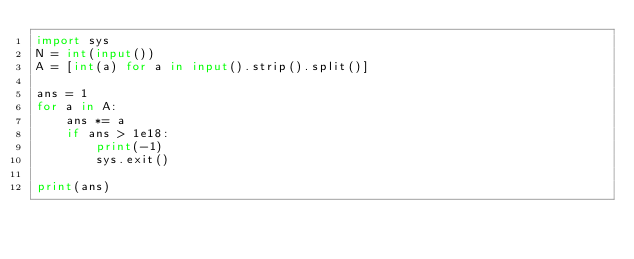<code> <loc_0><loc_0><loc_500><loc_500><_Python_>import sys
N = int(input())
A = [int(a) for a in input().strip().split()]

ans = 1
for a in A:
    ans *= a
    if ans > 1e18:
        print(-1)
        sys.exit()

print(ans)</code> 